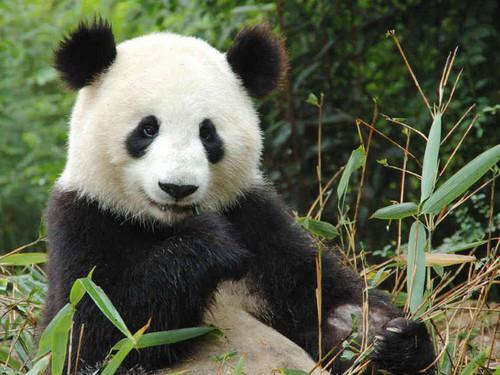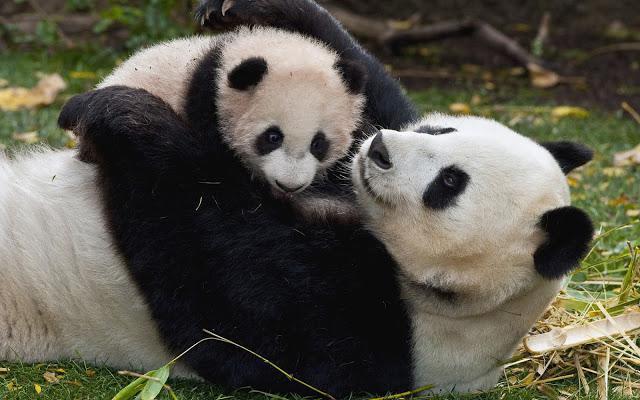The first image is the image on the left, the second image is the image on the right. For the images shown, is this caption "An image shows an adult panda on its back, playing with a young panda on top." true? Answer yes or no. Yes. The first image is the image on the left, the second image is the image on the right. Analyze the images presented: Is the assertion "There are three panda bears" valid? Answer yes or no. Yes. The first image is the image on the left, the second image is the image on the right. Assess this claim about the two images: "In one image, an adult panda is sitting upright with a baby panda sitting beside her.". Correct or not? Answer yes or no. No. 